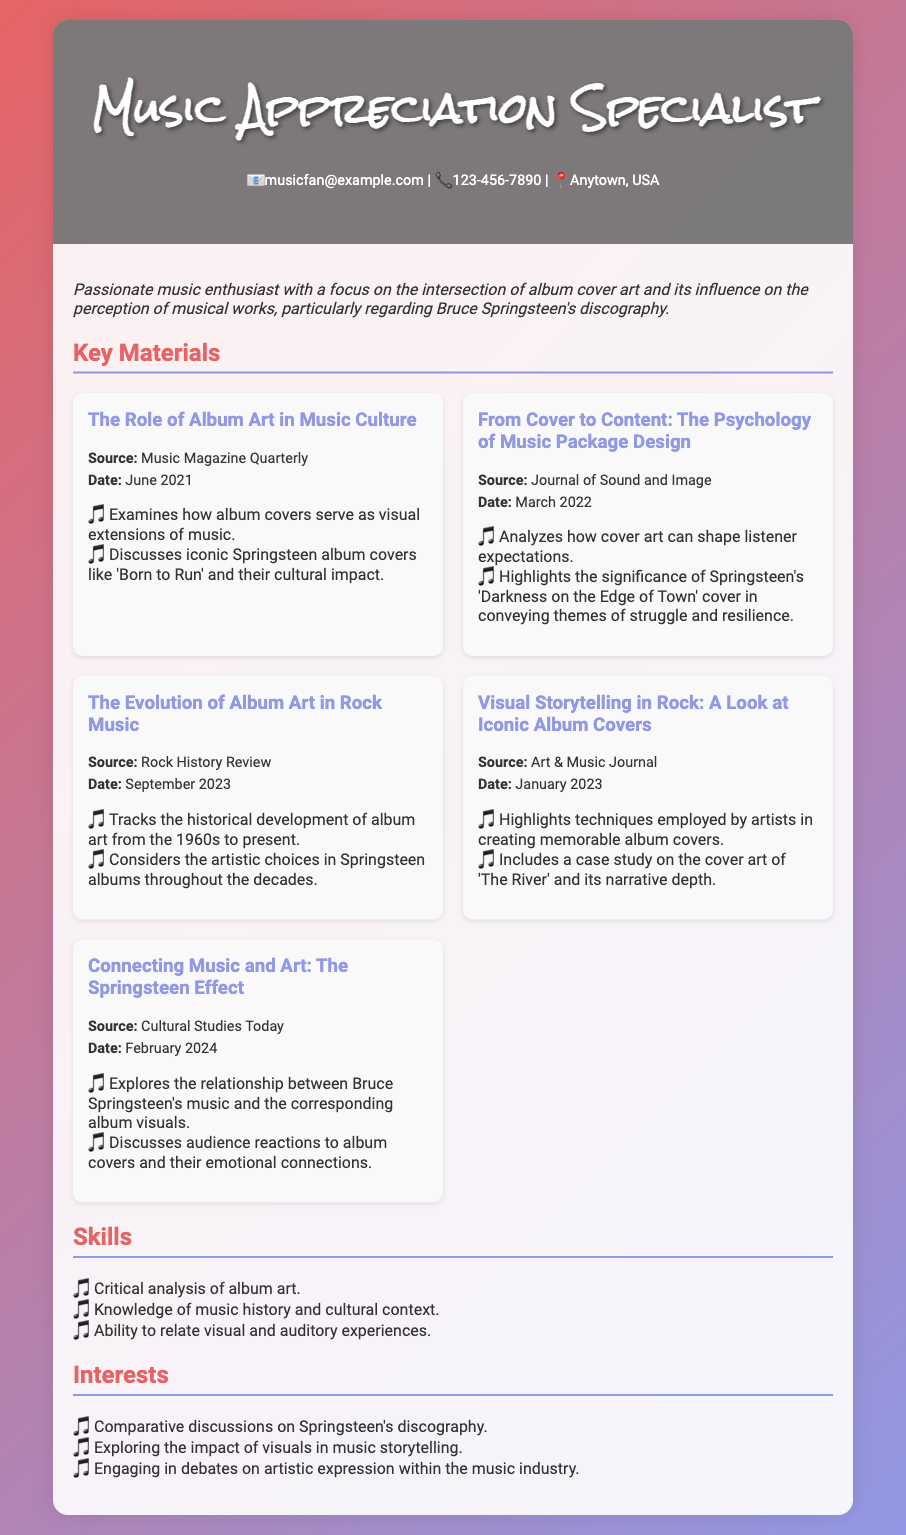What is the name of the specialist? The specialist's title is "Music Appreciation Specialist" as stated in the document.
Answer: Music Appreciation Specialist What is the email address provided? The email address listed in the contact information section is provided directly.
Answer: musicfan@example.com When was "From Cover to Content: The Psychology of Music Package Design" published? The date for this material is explicitly mentioned in the document.
Answer: March 2022 Which publication discusses the cultural impact of Springsteen's album covers? This specific publication is mentioned in the key materials section of the document.
Answer: Music Magazine Quarterly What are the skills listed in the CV? The document contains a specific list of skills under the "Skills" section.
Answer: Critical analysis of album art; Knowledge of music history and cultural context; Ability to relate visual and auditory experiences What topic does the material "Connecting Music and Art: The Springsteen Effect" explore? The document explicitly states the focus of this material in the description.
Answer: The relationship between Bruce Springsteen's music and the corresponding album visuals What is the date of the latest material listed? The date is clearly stated in the key materials section of the document.
Answer: February 2024 Which album cover is highlighted for its narrative depth? The document mentions this specific album cover in a case study.
Answer: The River What interest involves engaging in debates on artistic expression? The document describes specific interests including this particular interest.
Answer: Engaging in debates on artistic expression within the music industry 